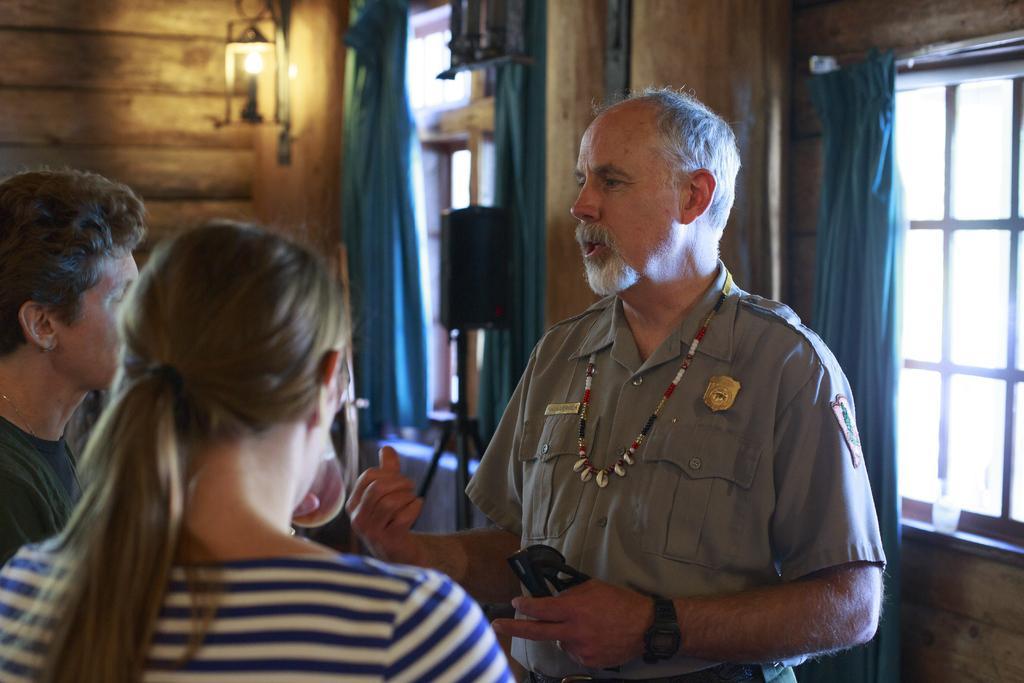Please provide a concise description of this image. In this image in the front there are persons standing. In the background there are curtains, windows, lights and there is an object which is black in colour and there is a wooden wall. 